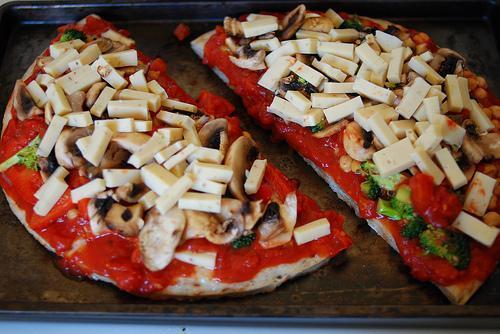How many pieces of pizza are there?
Give a very brief answer. 2. 